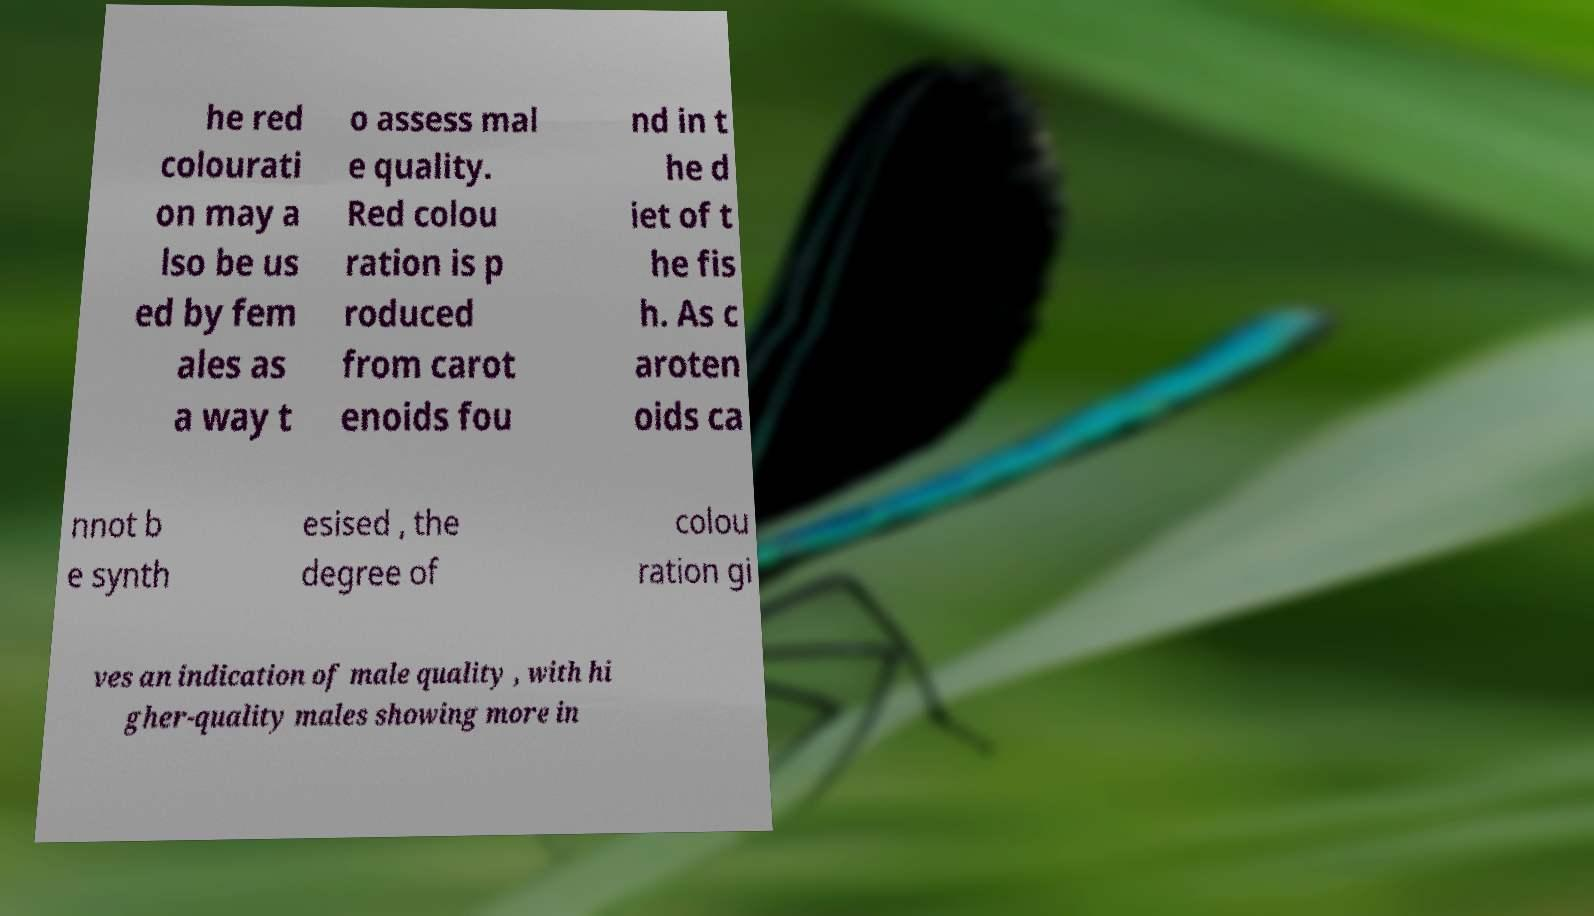What messages or text are displayed in this image? I need them in a readable, typed format. he red colourati on may a lso be us ed by fem ales as a way t o assess mal e quality. Red colou ration is p roduced from carot enoids fou nd in t he d iet of t he fis h. As c aroten oids ca nnot b e synth esised , the degree of colou ration gi ves an indication of male quality , with hi gher-quality males showing more in 